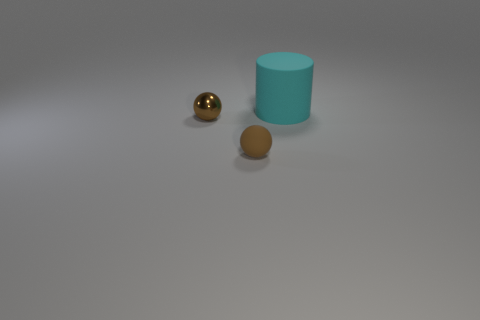Add 1 big yellow rubber things. How many objects exist? 4 Subtract 1 spheres. How many spheres are left? 1 Subtract all shiny spheres. Subtract all matte things. How many objects are left? 0 Add 2 large matte cylinders. How many large matte cylinders are left? 3 Add 1 shiny balls. How many shiny balls exist? 2 Subtract 0 gray cylinders. How many objects are left? 3 Subtract all spheres. How many objects are left? 1 Subtract all purple spheres. Subtract all blue cubes. How many spheres are left? 2 Subtract all gray cylinders. How many gray balls are left? 0 